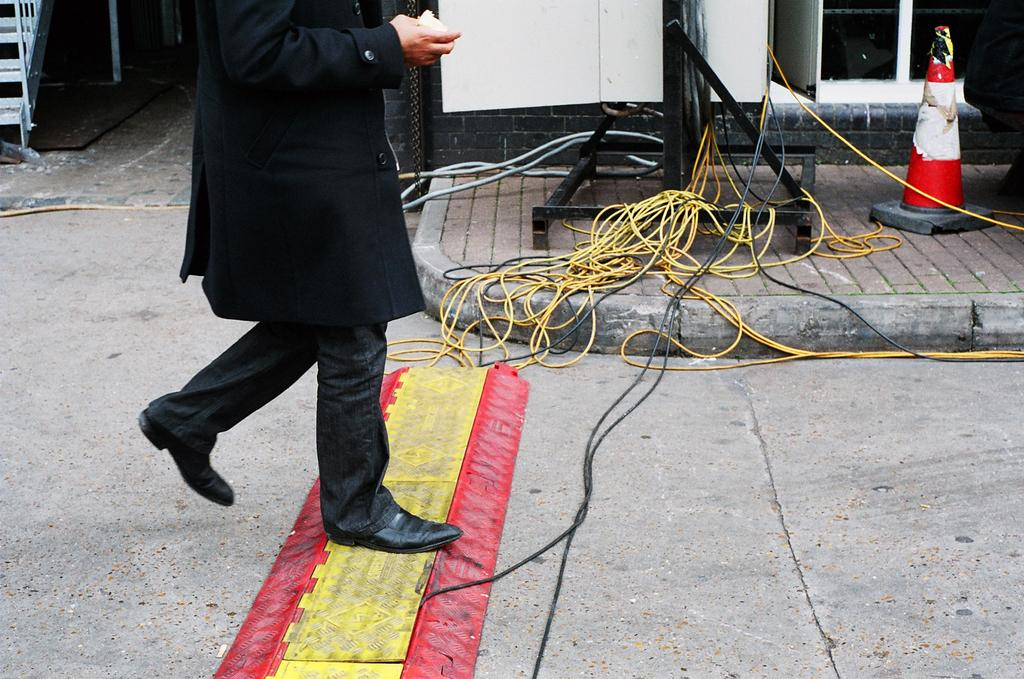What is the main subject of the image? There is a person walking in the image. What can be seen in the middle of the image? There are wires in the middle of the image. What object is located on the right side of the image? There is a traffic cone on the right side of the image. What architectural feature is on the left side of the image? There are stairs on the left side of the image. What color is the paint on the traffic cone in the image? There is no paint on the traffic cone in the image; it is a solid orange color. How many dimes can be seen on the stairs in the image? There are no dimes present in the image; it only features a person walking, wires, a traffic cone, and stairs. 